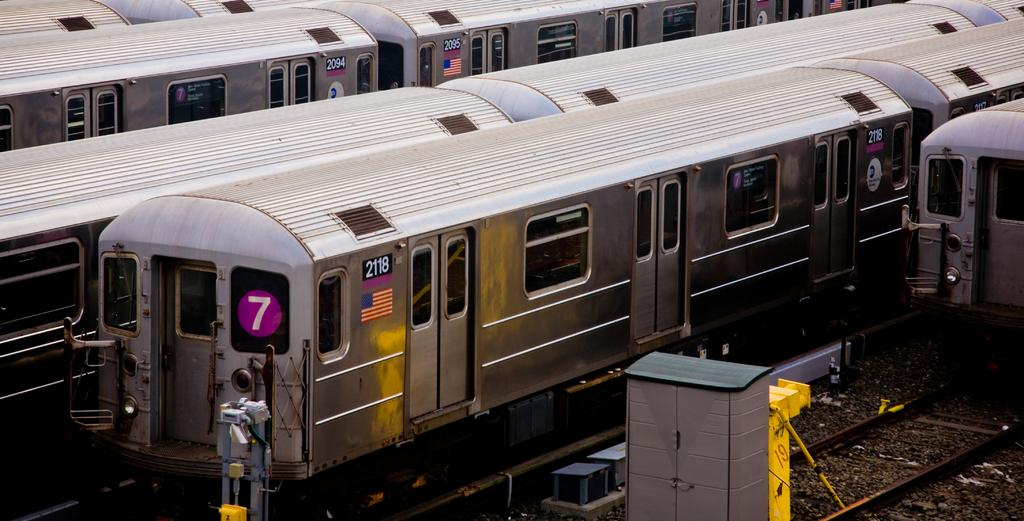What type of vehicles are on the tracks in the image? There are trains on the tracks in the image. What object is located beside the train? There is a box beside the train. What material are the rods in the image made of? The rods in the image are made of metal. What is the force exerted by the wish in the image? There is no wish present in the image, so it is not possible to determine the force exerted by it. 